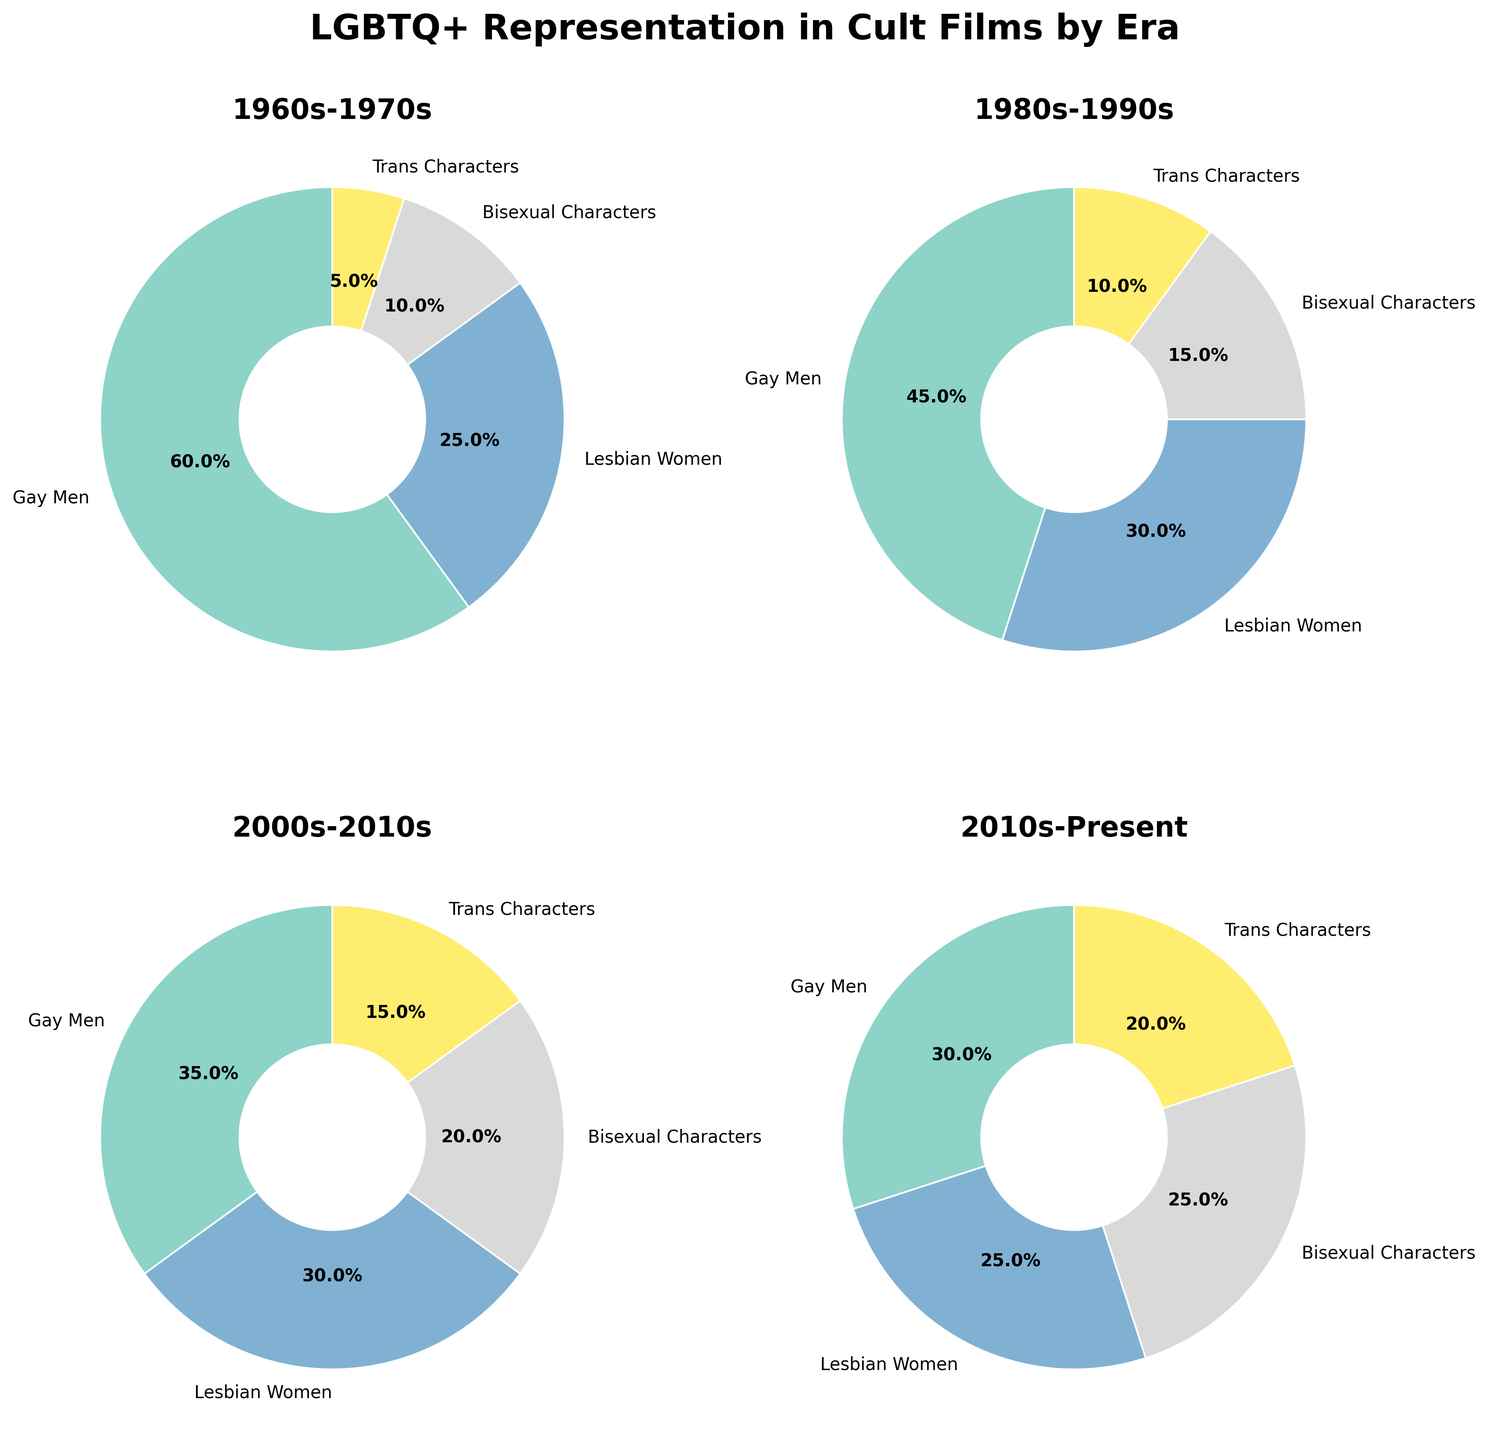What is the title of the Figure? The title is typically placed at the top center of the figure and provides an overview of the visualized data.
Answer: LGBTQ+ Representation in Cult Films by Era Which era has the highest percentage of Trans Characters? By looking at the pie charts, we can see that the 2010s-Present era has the segment with the highest percentage for Trans Characters at 20%.
Answer: 2010s-Present How does the representation of Gay Men change from the 1960s-1970s to the 2010s-Present? In the 1960s-1970s, Gay Men make up 60% of the characters. This percentage decreases to 30% in the 2010s-Present. Thus, representation decreased by 30 percentage points over these eras.
Answer: Decreases by 30 percentage points Which era shows the most balanced representation of LGBTQ+ character types? The most balanced representation would be the era with the smallest range between the highest and lowest percentages of different character types. In the 2010s-Present, the percentages are 30%, 25%, 25%, and 20%. The difference between the highest and lowest values is 10 percentage points, making it the most balanced.
Answer: 2010s-Present What is the total percentage of Bisexual Characters in the 2000s-2010s and the 2010s-Present combined? In the 2000s-2010s, Bisexual Characters make up 20%, and in the 2010s-Present, they also make up 25%. Adding these percentages results in a combined total of 45%.
Answer: 45% Compare the representation of Lesbian Women in the 1980s-1990s and the 2010s-Present. Which era has a higher percentage? In the 1980s-1990s, Lesbian Women represent 30%, while in the 2010s-Present, they represent 25%. Thus, Lesbian Women have a higher representation in the 1980s-1990s by 5 percentage points.
Answer: 1980s-1990s Which LGBTQ+ character type showed the most significant increase in representation from the 1960s-1970s to the 2010s-Present? To find the most significant increase, compare the percentage changes across all character types. Gay Men decreased, Lesbian Women increased by 0%, Bisexual Characters increased by 15%, and Trans Characters increased by 15%. Both Bisexual and Trans Characters show the largest increase of 15 percentage points.
Answer: Bisexual Characters and Trans Characters What is the percentage difference in representation between Gay Men and Lesbian Women in the 1960s-1970s? Gay Men represent 60% and Lesbian Women represent 25% in the 1960s-1970s. The difference is calculated as 60% - 25% = 35%.
Answer: 35% List all eras in which Bisexual Characters' representation increased compared to the previous era The representation of Bisexual Characters increased from the 1960s-1970s (10%) to the 1980s-1990s (15%), from the 1980s-1990s (15%) to the 2000s-2010s (20%), and from the 2000s-2010s (20%) to the 2010s-Present (25%). Therefore, Bisexual Characters' representation increased in all subsequent eras.
Answer: All eras 